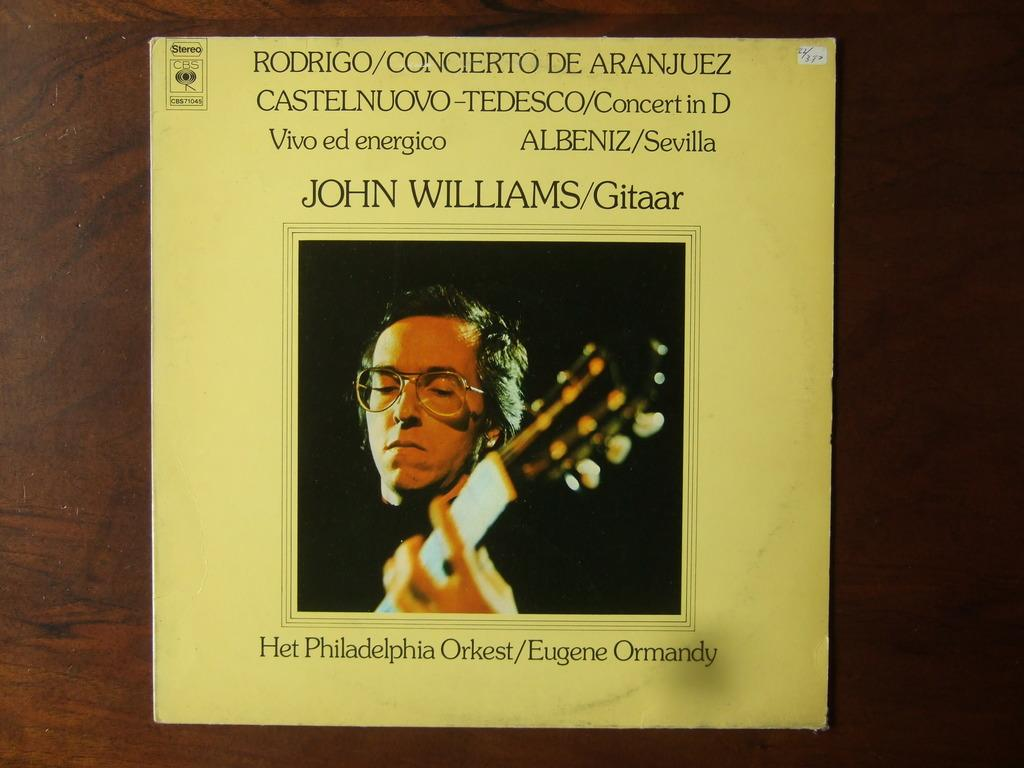Provide a one-sentence caption for the provided image. A yellow colored album named Het Philadelphia Orkest. 